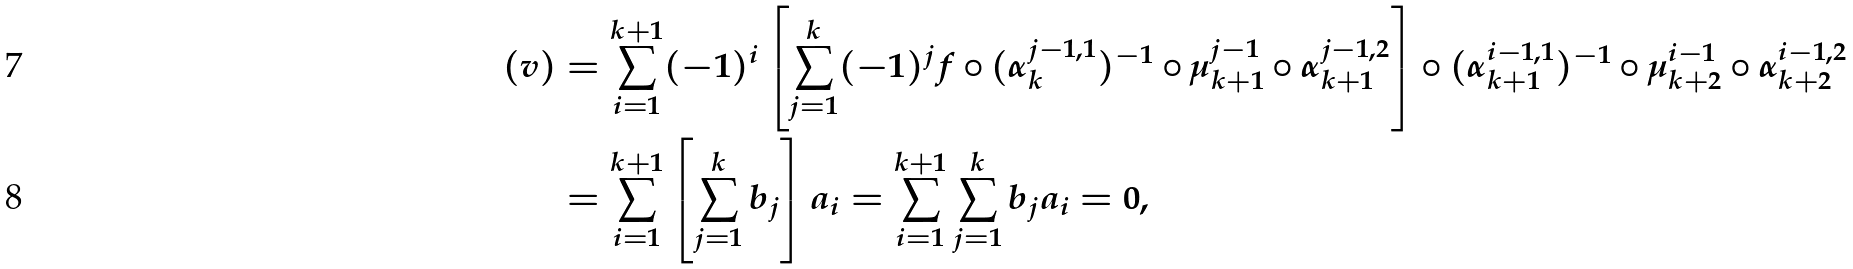Convert formula to latex. <formula><loc_0><loc_0><loc_500><loc_500>( v ) & = \sum ^ { k + 1 } _ { i = 1 } ( - 1 ) ^ { i } \left [ \sum ^ { k } _ { j = 1 } ( - 1 ) ^ { j } f \circ ( \alpha ^ { j - 1 , 1 } _ { k } ) ^ { - 1 } \circ \mu ^ { j - 1 } _ { k + 1 } \circ \alpha ^ { j - 1 , 2 } _ { k + 1 } \right ] \circ ( \alpha ^ { i - 1 , 1 } _ { k + 1 } ) ^ { - 1 } \circ \mu ^ { i - 1 } _ { k + 2 } \circ \alpha ^ { i - 1 , 2 } _ { k + 2 } \\ & = \sum ^ { k + 1 } _ { i = 1 } \left [ \sum ^ { k } _ { j = 1 } b _ { j } \right ] a _ { i } = \sum ^ { k + 1 } _ { i = 1 } \sum ^ { k } _ { j = 1 } b _ { j } a _ { i } = 0 ,</formula> 